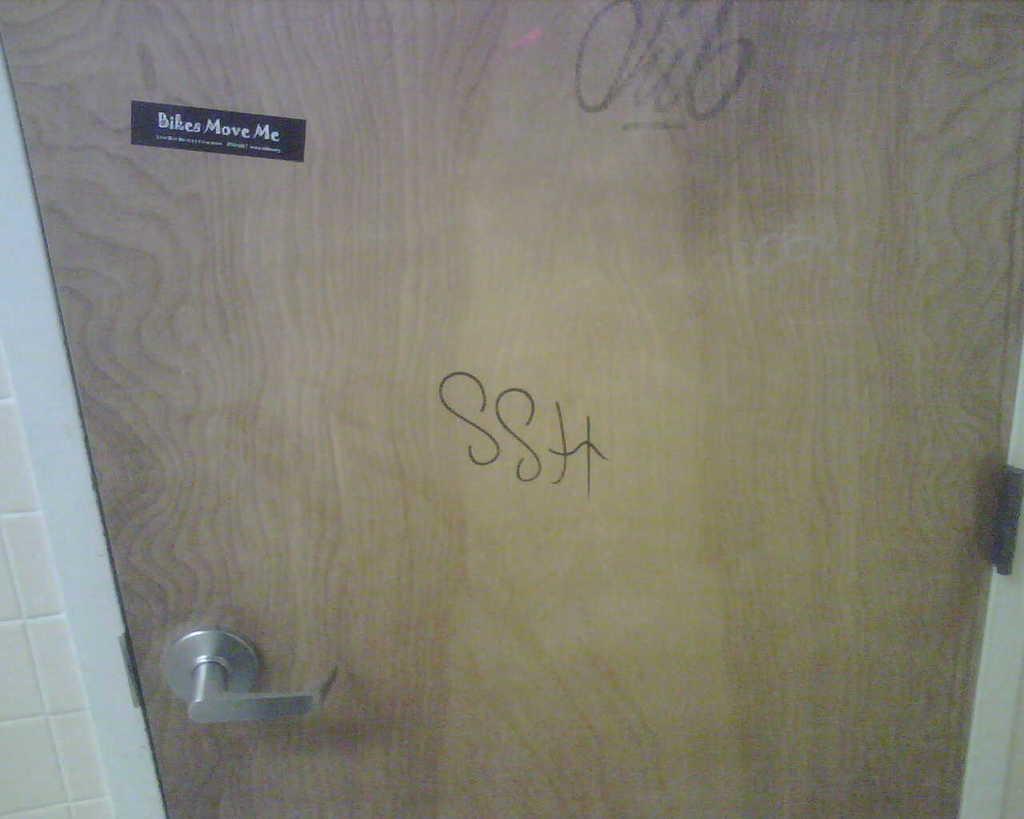In one or two sentences, can you explain what this image depicts? In this picture we can see the wall, door with a handle and on this door we can see a sticker and some text. 